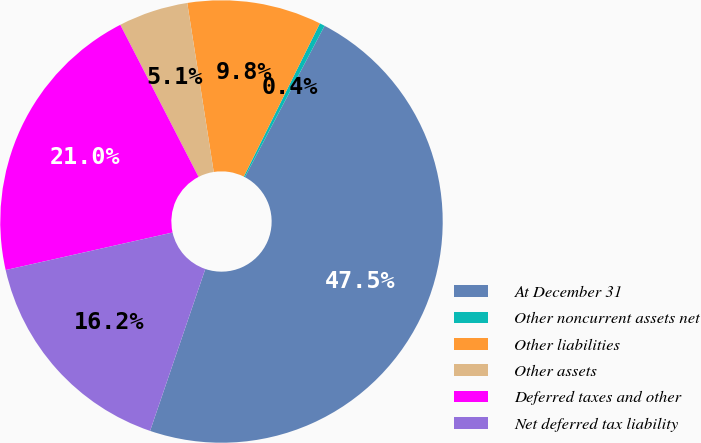<chart> <loc_0><loc_0><loc_500><loc_500><pie_chart><fcel>At December 31<fcel>Other noncurrent assets net<fcel>Other liabilities<fcel>Other assets<fcel>Deferred taxes and other<fcel>Net deferred tax liability<nl><fcel>47.52%<fcel>0.38%<fcel>9.81%<fcel>5.09%<fcel>20.96%<fcel>16.25%<nl></chart> 